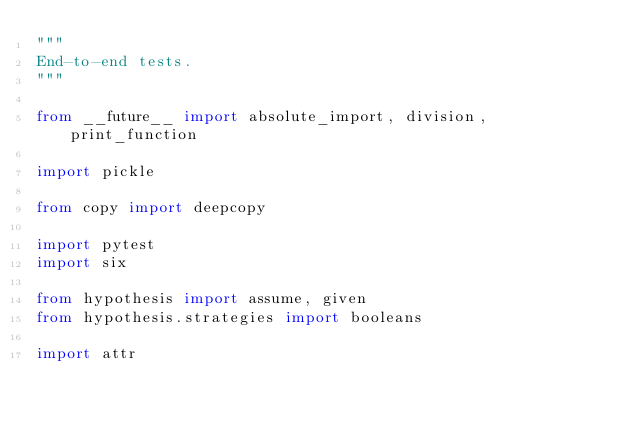<code> <loc_0><loc_0><loc_500><loc_500><_Python_>"""
End-to-end tests.
"""

from __future__ import absolute_import, division, print_function

import pickle

from copy import deepcopy

import pytest
import six

from hypothesis import assume, given
from hypothesis.strategies import booleans

import attr
</code> 